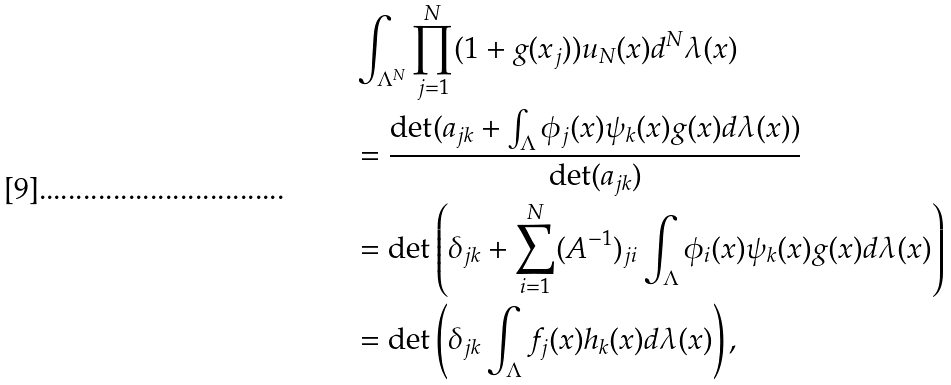<formula> <loc_0><loc_0><loc_500><loc_500>& \int _ { \Lambda ^ { N } } \prod _ { j = 1 } ^ { N } ( 1 + g ( x _ { j } ) ) u _ { N } ( x ) d ^ { N } \lambda ( x ) \\ & = \frac { \det ( a _ { j k } + \int _ { \Lambda } \phi _ { j } ( x ) \psi _ { k } ( x ) g ( x ) d \lambda ( x ) ) } { \det ( a _ { j k } ) } \\ & = \det \left ( \delta _ { j k } + \sum _ { i = 1 } ^ { N } ( A ^ { - 1 } ) _ { j i } \int _ { \Lambda } \phi _ { i } ( x ) \psi _ { k } ( x ) g ( x ) d \lambda ( x ) \right ) \\ & = \det \left ( \delta _ { j k } \int _ { \Lambda } f _ { j } ( x ) h _ { k } ( x ) d \lambda ( x ) \right ) ,</formula> 